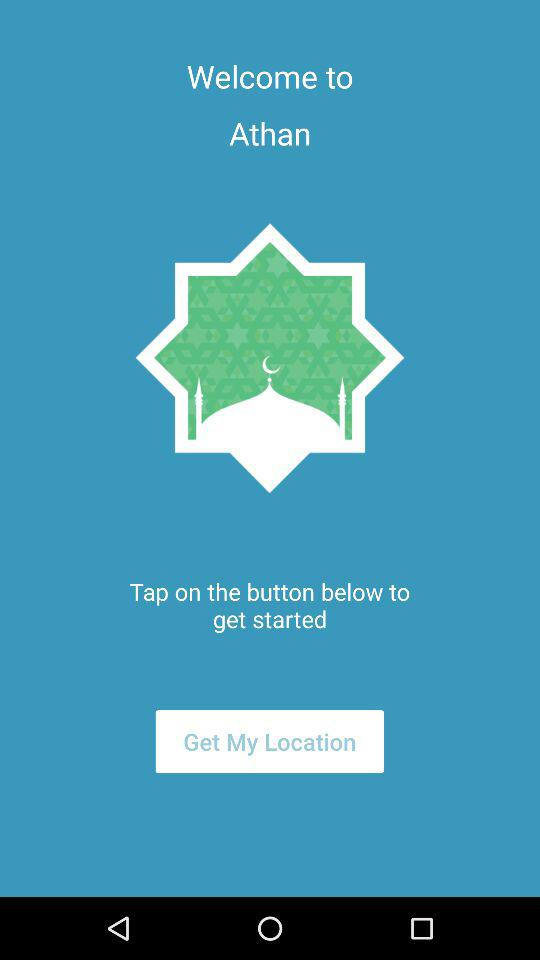What is the application name? The application name is "Athan". 